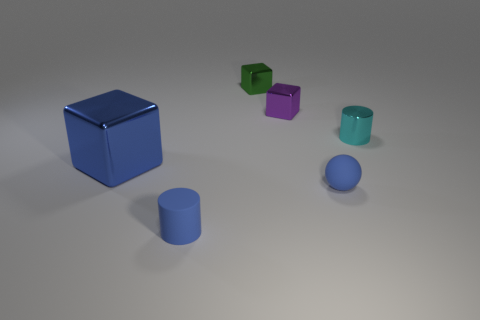Add 3 small matte things. How many objects exist? 9 Subtract all balls. How many objects are left? 5 Add 6 tiny metal cylinders. How many tiny metal cylinders exist? 7 Subtract 0 yellow spheres. How many objects are left? 6 Subtract all blue cubes. Subtract all big yellow matte spheres. How many objects are left? 5 Add 3 blue matte cylinders. How many blue matte cylinders are left? 4 